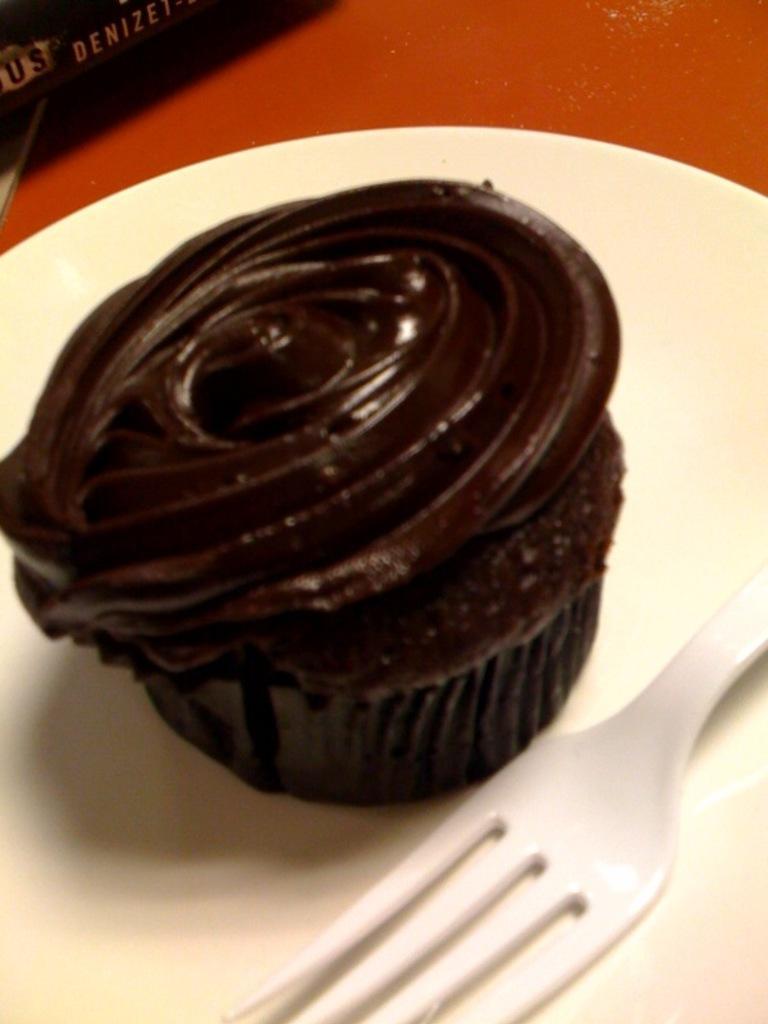Describe this image in one or two sentences. In the center of the image there is a cupcake and a fork which are placed on the plate. 